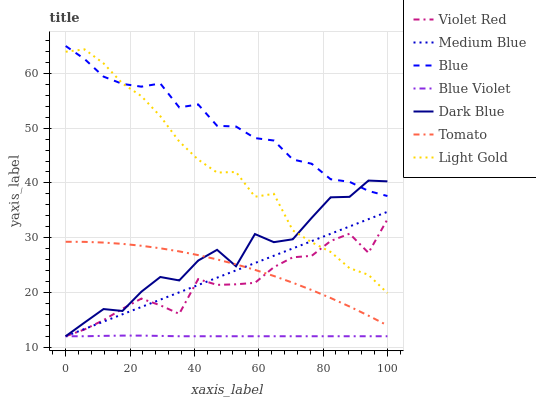Does Blue Violet have the minimum area under the curve?
Answer yes or no. Yes. Does Blue have the maximum area under the curve?
Answer yes or no. Yes. Does Tomato have the minimum area under the curve?
Answer yes or no. No. Does Tomato have the maximum area under the curve?
Answer yes or no. No. Is Medium Blue the smoothest?
Answer yes or no. Yes. Is Dark Blue the roughest?
Answer yes or no. Yes. Is Tomato the smoothest?
Answer yes or no. No. Is Tomato the roughest?
Answer yes or no. No. Does Violet Red have the lowest value?
Answer yes or no. Yes. Does Tomato have the lowest value?
Answer yes or no. No. Does Blue have the highest value?
Answer yes or no. Yes. Does Tomato have the highest value?
Answer yes or no. No. Is Violet Red less than Blue?
Answer yes or no. Yes. Is Blue greater than Tomato?
Answer yes or no. Yes. Does Blue Violet intersect Dark Blue?
Answer yes or no. Yes. Is Blue Violet less than Dark Blue?
Answer yes or no. No. Is Blue Violet greater than Dark Blue?
Answer yes or no. No. Does Violet Red intersect Blue?
Answer yes or no. No. 